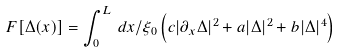Convert formula to latex. <formula><loc_0><loc_0><loc_500><loc_500>F [ \Delta ( x ) ] = \int _ { 0 } ^ { L } \, d x / \xi _ { 0 } \left ( c | \partial _ { x } \Delta | ^ { 2 } + a | \Delta | ^ { 2 } + b | \Delta | ^ { 4 } \right )</formula> 